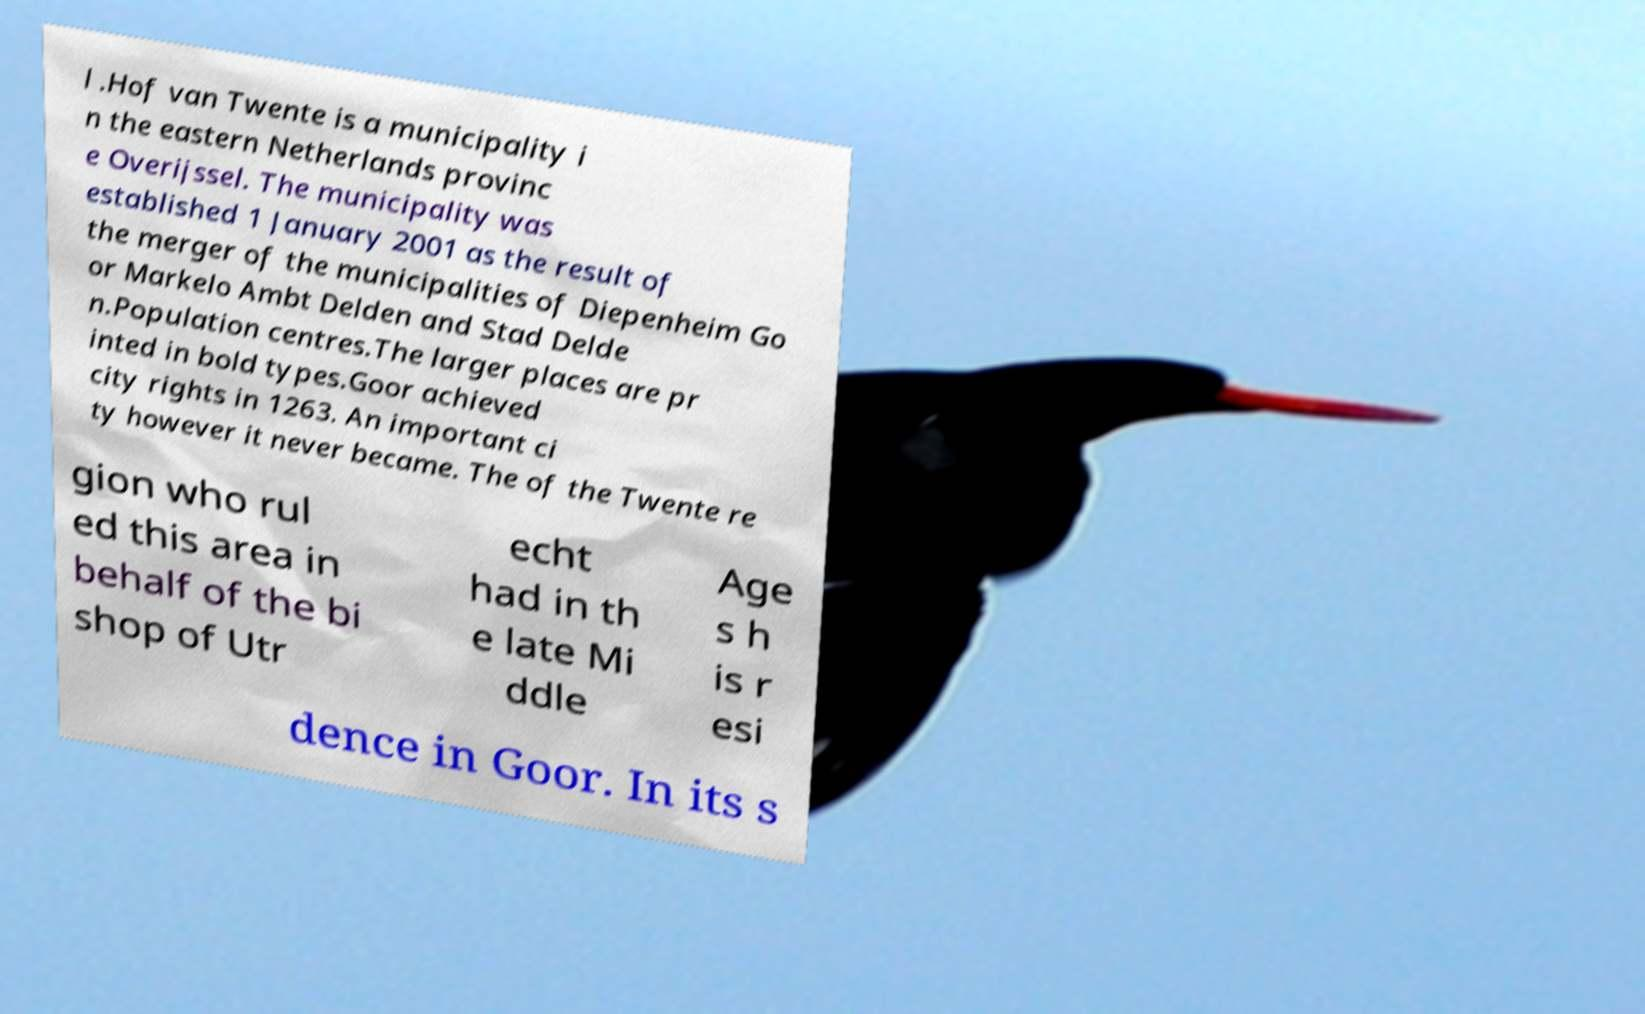I need the written content from this picture converted into text. Can you do that? l .Hof van Twente is a municipality i n the eastern Netherlands provinc e Overijssel. The municipality was established 1 January 2001 as the result of the merger of the municipalities of Diepenheim Go or Markelo Ambt Delden and Stad Delde n.Population centres.The larger places are pr inted in bold types.Goor achieved city rights in 1263. An important ci ty however it never became. The of the Twente re gion who rul ed this area in behalf of the bi shop of Utr echt had in th e late Mi ddle Age s h is r esi dence in Goor. In its s 